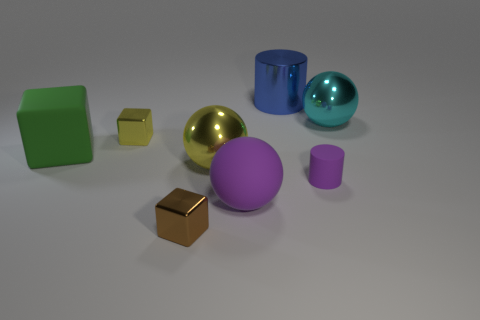Add 1 metallic objects. How many objects exist? 9 Subtract all cylinders. How many objects are left? 6 Subtract 1 yellow spheres. How many objects are left? 7 Subtract all small gray matte cylinders. Subtract all spheres. How many objects are left? 5 Add 1 big cyan things. How many big cyan things are left? 2 Add 3 tiny purple objects. How many tiny purple objects exist? 4 